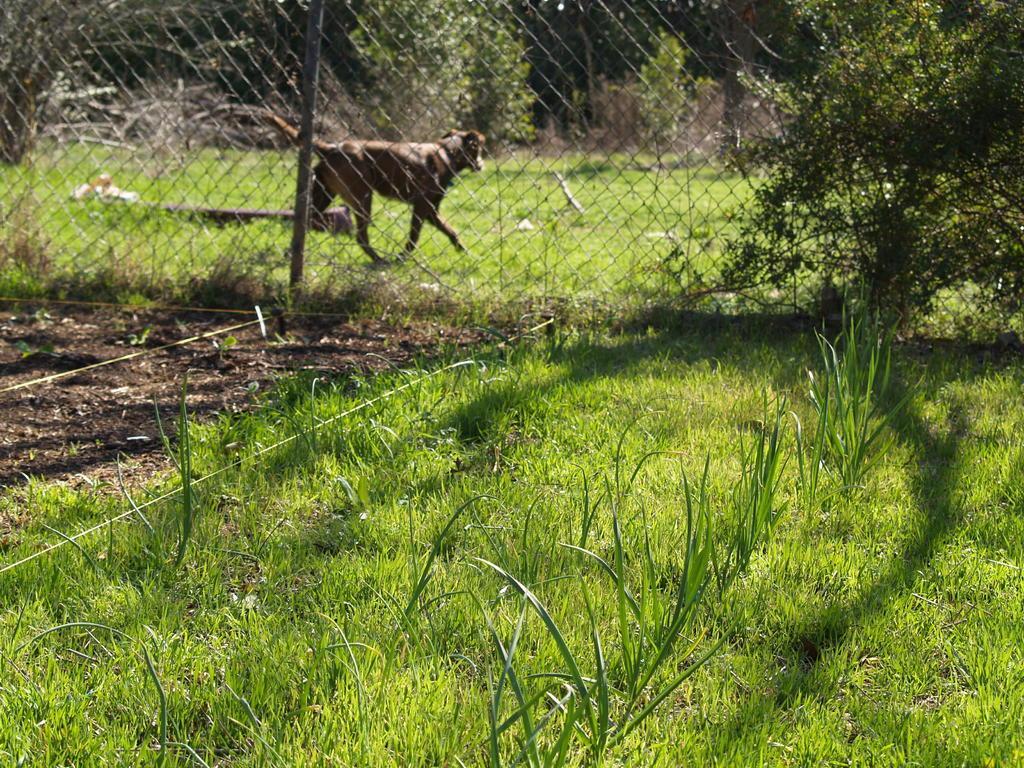Could you give a brief overview of what you see in this image? This is the grass and plants. This looks like a fence. I can see a dog walking behind the fence. These are the trees. 